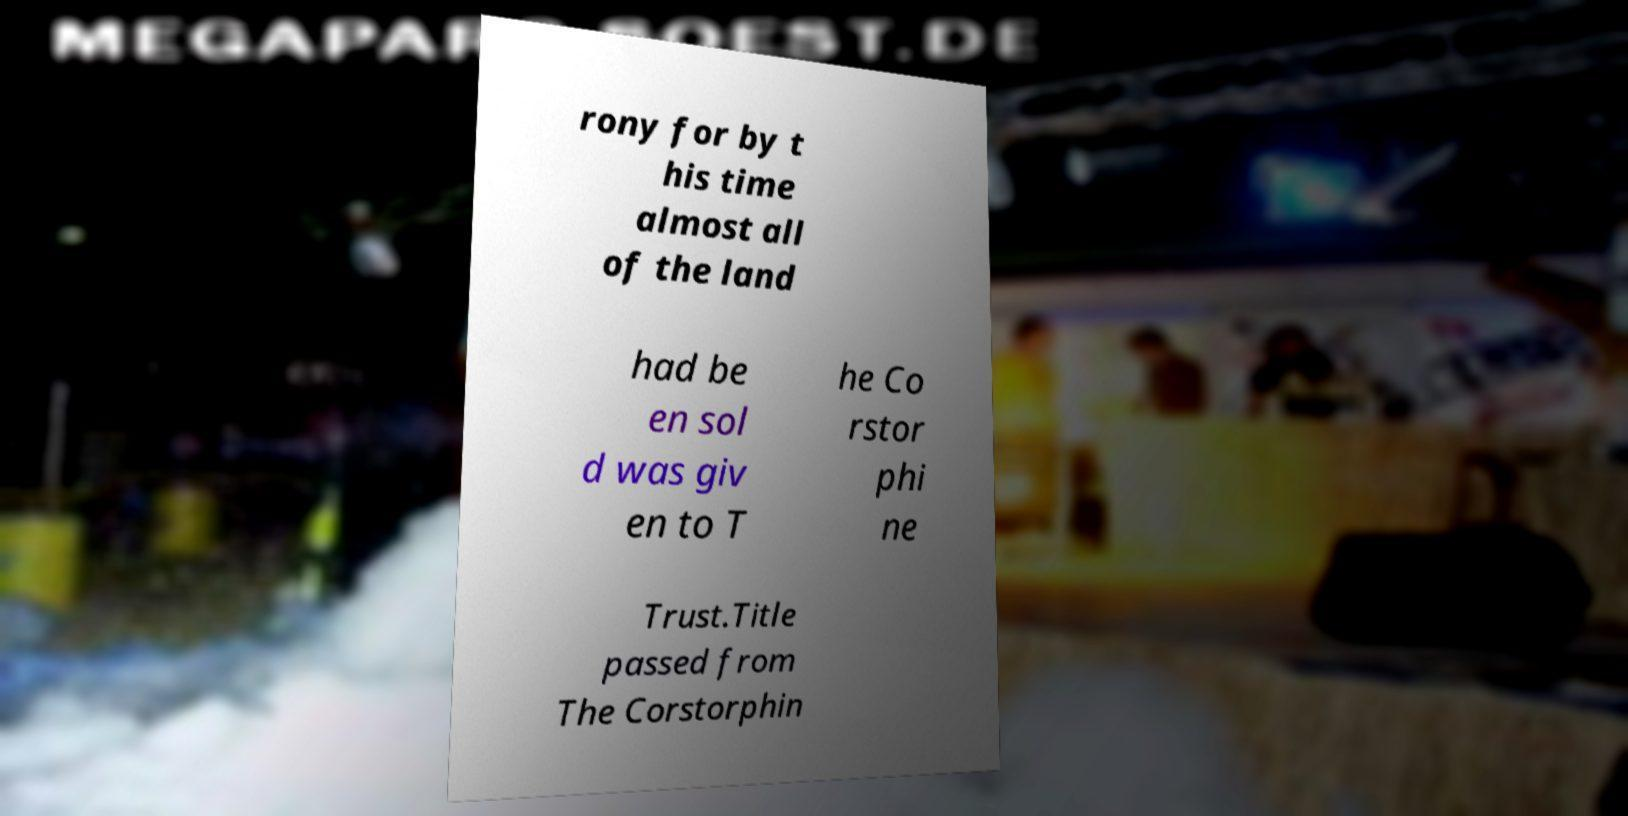Can you accurately transcribe the text from the provided image for me? rony for by t his time almost all of the land had be en sol d was giv en to T he Co rstor phi ne Trust.Title passed from The Corstorphin 